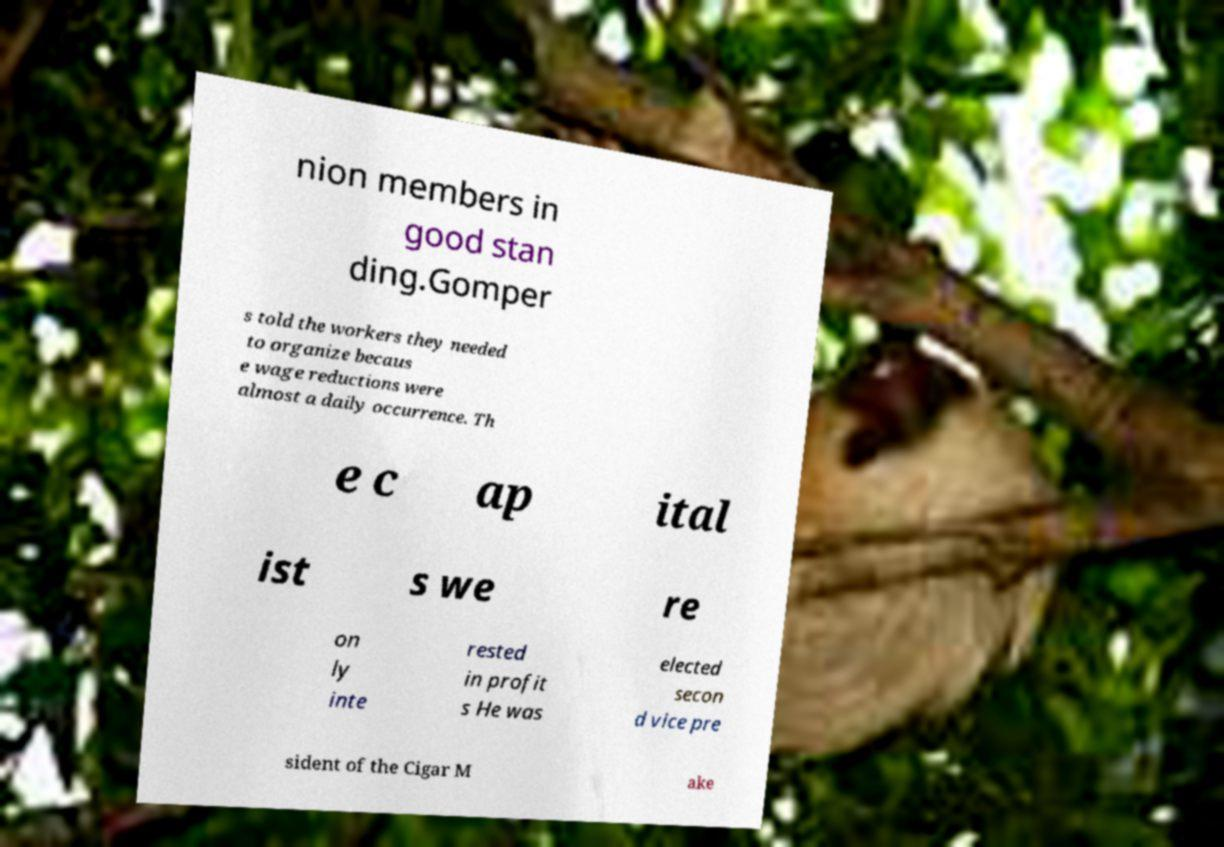Can you accurately transcribe the text from the provided image for me? nion members in good stan ding.Gomper s told the workers they needed to organize becaus e wage reductions were almost a daily occurrence. Th e c ap ital ist s we re on ly inte rested in profit s He was elected secon d vice pre sident of the Cigar M ake 